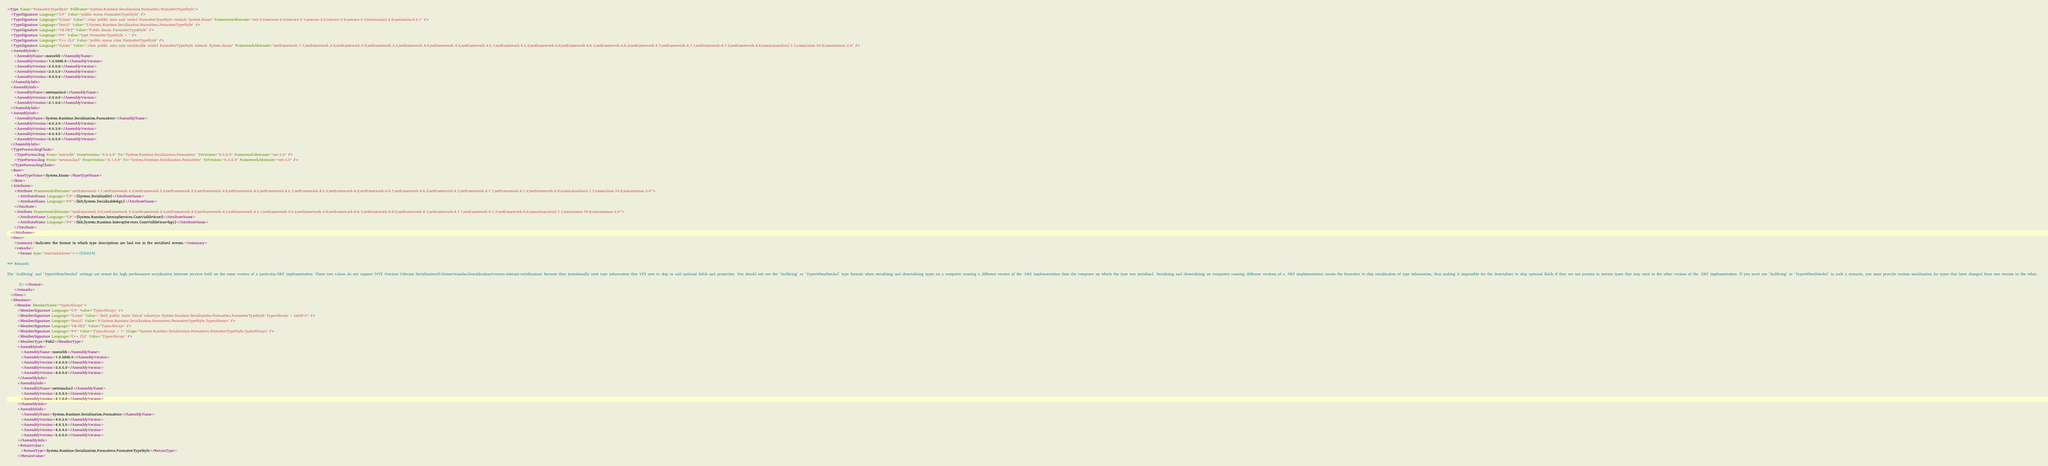Convert code to text. <code><loc_0><loc_0><loc_500><loc_500><_XML_><Type Name="FormatterTypeStyle" FullName="System.Runtime.Serialization.Formatters.FormatterTypeStyle">
  <TypeSignature Language="C#" Value="public enum FormatterTypeStyle" />
  <TypeSignature Language="ILAsm" Value=".class public auto ansi sealed FormatterTypeStyle extends System.Enum" FrameworkAlternate="net-5.0;netcore-2.0;netcore-2.1;netcore-2.2;netcore-3.0;netcore-3.1;netstandard-2.0;netstandard-2.1" />
  <TypeSignature Language="DocId" Value="T:System.Runtime.Serialization.Formatters.FormatterTypeStyle" />
  <TypeSignature Language="VB.NET" Value="Public Enum FormatterTypeStyle" />
  <TypeSignature Language="F#" Value="type FormatterTypeStyle = " />
  <TypeSignature Language="C++ CLI" Value="public enum class FormatterTypeStyle" />
  <TypeSignature Language="ILAsm" Value=".class public auto ansi serializable sealed FormatterTypeStyle extends System.Enum" FrameworkAlternate="netframework-1.1;netframework-2.0;netframework-3.0;netframework-3.5;netframework-4.0;netframework-4.5;netframework-4.5.1;netframework-4.5.2;netframework-4.6;netframework-4.6.1;netframework-4.6.2;netframework-4.7;netframework-4.7.1;netframework-4.7.2;netframework-4.8;xamarinandroid-7.1;xamarinios-10.8;xamarinmac-3.0" />
  <AssemblyInfo>
    <AssemblyName>mscorlib</AssemblyName>
    <AssemblyVersion>1.0.5000.0</AssemblyVersion>
    <AssemblyVersion>2.0.0.0</AssemblyVersion>
    <AssemblyVersion>2.0.5.0</AssemblyVersion>
    <AssemblyVersion>4.0.0.0</AssemblyVersion>
  </AssemblyInfo>
  <AssemblyInfo>
    <AssemblyName>netstandard</AssemblyName>
    <AssemblyVersion>2.0.0.0</AssemblyVersion>
    <AssemblyVersion>2.1.0.0</AssemblyVersion>
  </AssemblyInfo>
  <AssemblyInfo>
    <AssemblyName>System.Runtime.Serialization.Formatters</AssemblyName>
    <AssemblyVersion>4.0.2.0</AssemblyVersion>
    <AssemblyVersion>4.0.3.0</AssemblyVersion>
    <AssemblyVersion>4.0.4.0</AssemblyVersion>
    <AssemblyVersion>5.0.0.0</AssemblyVersion>
  </AssemblyInfo>
  <TypeForwardingChain>
    <TypeForwarding From="mscorlib" FromVersion="4.0.0.0" To="System.Runtime.Serialization.Formatters" ToVersion="0.0.0.0" FrameworkAlternate="net-5.0" />
    <TypeForwarding From="netstandard" FromVersion="2.1.0.0" To="System.Runtime.Serialization.Formatters" ToVersion="5.0.0.0" FrameworkAlternate="net-5.0" />
  </TypeForwardingChain>
  <Base>
    <BaseTypeName>System.Enum</BaseTypeName>
  </Base>
  <Attributes>
    <Attribute FrameworkAlternate="netframework-1.1;netframework-2.0;netframework-3.0;netframework-3.5;netframework-4.0;netframework-4.5;netframework-4.5.1;netframework-4.5.2;netframework-4.6;netframework-4.6.1;netframework-4.6.2;netframework-4.7;netframework-4.7.1;netframework-4.7.2;netframework-4.8;xamarinandroid-7.1;xamarinios-10.8;xamarinmac-3.0">
      <AttributeName Language="C#">[System.Serializable]</AttributeName>
      <AttributeName Language="F#">[&lt;System.Serializable&gt;]</AttributeName>
    </Attribute>
    <Attribute FrameworkAlternate="netframework-2.0;netframework-3.0;netframework-3.5;netframework-4.0;netframework-4.5;netframework-4.5.1;netframework-4.5.2;netframework-4.6;netframework-4.6.1;netframework-4.6.2;netframework-4.7;netframework-4.7.1;netframework-4.7.2;netframework-4.8;xamarinandroid-7.1;xamarinios-10.8;xamarinmac-3.0">
      <AttributeName Language="C#">[System.Runtime.InteropServices.ComVisible(true)]</AttributeName>
      <AttributeName Language="F#">[&lt;System.Runtime.InteropServices.ComVisible(true)&gt;]</AttributeName>
    </Attribute>
  </Attributes>
  <Docs>
    <summary>Indicates the format in which type descriptions are laid out in the serialized stream.</summary>
    <remarks>
      <format type="text/markdown"><![CDATA[  
  
## Remarks  

The `XsdString` and `TypesWhenNeeded` settings are meant for high performance serialization between services built on the same version of a particular.NET implementation. These two values do not support [VTS (Version Tolerant Serialization)](/dotnet/standard/serialization/version-tolerant-serialization) because they intentionally omit type information that VTS uses to skip or add optional fields and properties. You should not use the `XsdString` or `TypesWhenNeeded` type formats when serializing and deserializing types on a computer running a different version of the .NET implementation than the computer on which the type was serialized. Serializing and deserializing on computers running different versions of a .NET implementation causes the formatter to skip serialization of type information, thus making it impossible for the deserializer to skip optional fields if they are not present in certain types that may exist in the other version of the .NET implementation. If you must use `XsdString` or `TypesWhenNeeded` in such a scenario, you must provide custom serialization for types that have changed from one version to the other.  
  
       ]]></format>
    </remarks>
  </Docs>
  <Members>
    <Member MemberName="TypesAlways">
      <MemberSignature Language="C#" Value="TypesAlways" />
      <MemberSignature Language="ILAsm" Value=".field public static literal valuetype System.Runtime.Serialization.Formatters.FormatterTypeStyle TypesAlways = int32(1)" />
      <MemberSignature Language="DocId" Value="F:System.Runtime.Serialization.Formatters.FormatterTypeStyle.TypesAlways" />
      <MemberSignature Language="VB.NET" Value="TypesAlways" />
      <MemberSignature Language="F#" Value="TypesAlways = 1" Usage="System.Runtime.Serialization.Formatters.FormatterTypeStyle.TypesAlways" />
      <MemberSignature Language="C++ CLI" Value="TypesAlways" />
      <MemberType>Field</MemberType>
      <AssemblyInfo>
        <AssemblyName>mscorlib</AssemblyName>
        <AssemblyVersion>1.0.5000.0</AssemblyVersion>
        <AssemblyVersion>2.0.0.0</AssemblyVersion>
        <AssemblyVersion>2.0.5.0</AssemblyVersion>
        <AssemblyVersion>4.0.0.0</AssemblyVersion>
      </AssemblyInfo>
      <AssemblyInfo>
        <AssemblyName>netstandard</AssemblyName>
        <AssemblyVersion>2.0.0.0</AssemblyVersion>
        <AssemblyVersion>2.1.0.0</AssemblyVersion>
      </AssemblyInfo>
      <AssemblyInfo>
        <AssemblyName>System.Runtime.Serialization.Formatters</AssemblyName>
        <AssemblyVersion>4.0.2.0</AssemblyVersion>
        <AssemblyVersion>4.0.3.0</AssemblyVersion>
        <AssemblyVersion>4.0.4.0</AssemblyVersion>
        <AssemblyVersion>5.0.0.0</AssemblyVersion>
      </AssemblyInfo>
      <ReturnValue>
        <ReturnType>System.Runtime.Serialization.Formatters.FormatterTypeStyle</ReturnType>
      </ReturnValue></code> 